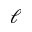<formula> <loc_0><loc_0><loc_500><loc_500>\boldsymbol \ell</formula> 